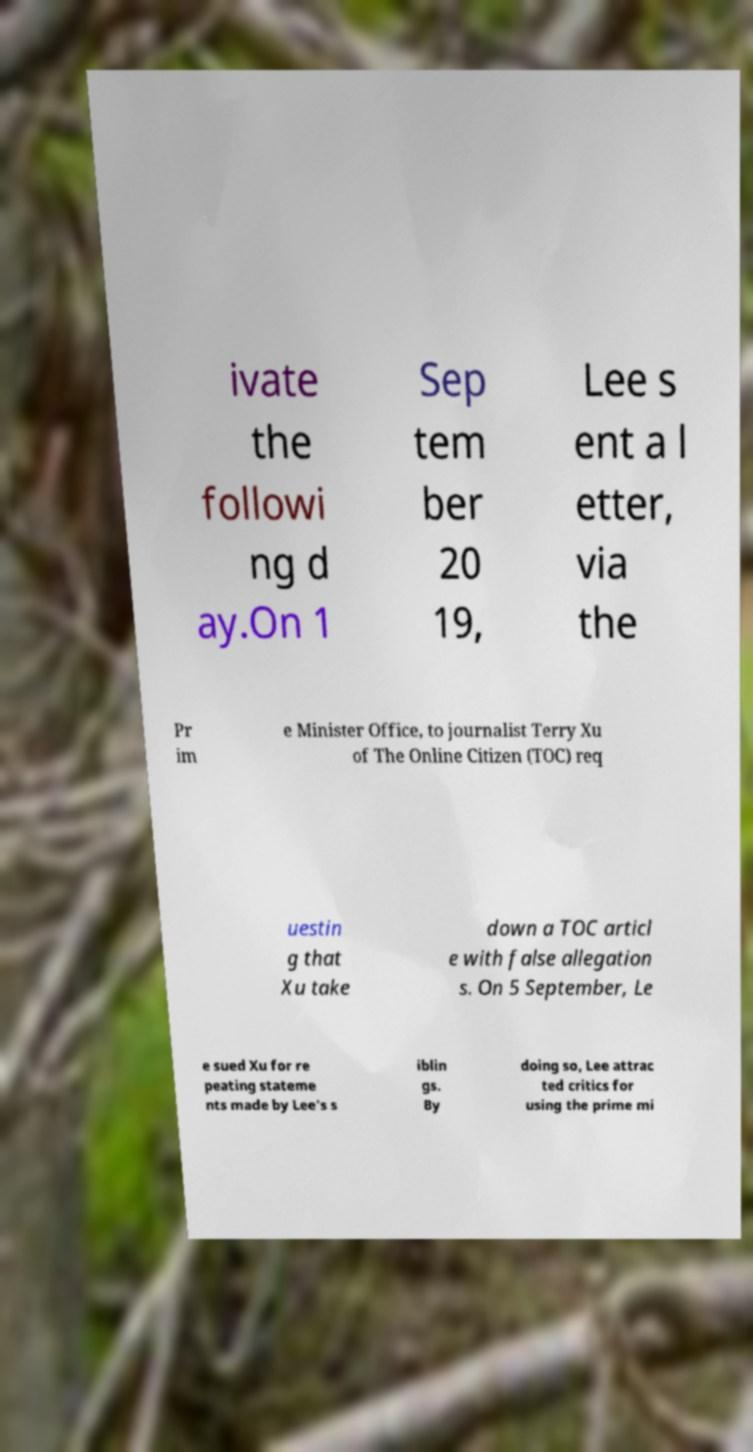Can you accurately transcribe the text from the provided image for me? ivate the followi ng d ay.On 1 Sep tem ber 20 19, Lee s ent a l etter, via the Pr im e Minister Office, to journalist Terry Xu of The Online Citizen (TOC) req uestin g that Xu take down a TOC articl e with false allegation s. On 5 September, Le e sued Xu for re peating stateme nts made by Lee's s iblin gs. By doing so, Lee attrac ted critics for using the prime mi 